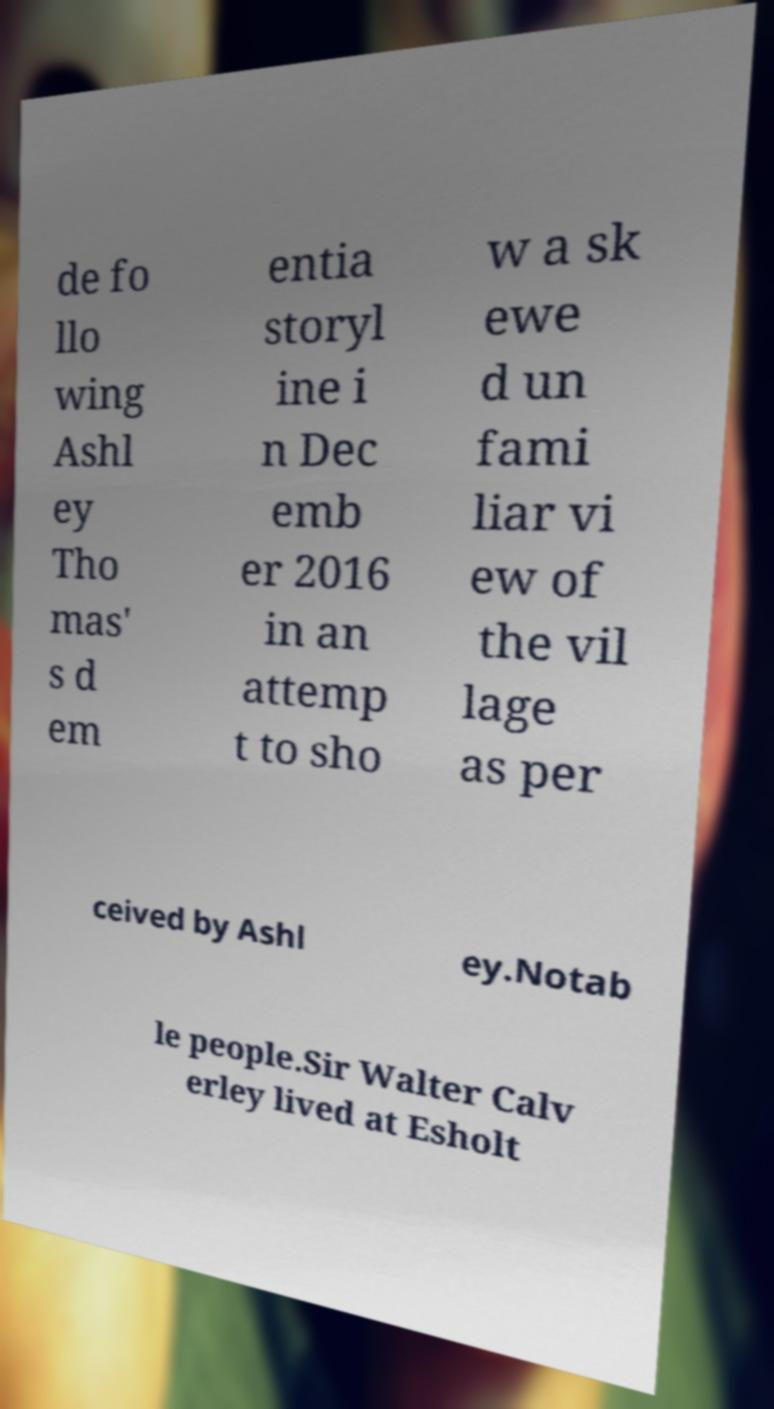Please read and relay the text visible in this image. What does it say? de fo llo wing Ashl ey Tho mas' s d em entia storyl ine i n Dec emb er 2016 in an attemp t to sho w a sk ewe d un fami liar vi ew of the vil lage as per ceived by Ashl ey.Notab le people.Sir Walter Calv erley lived at Esholt 